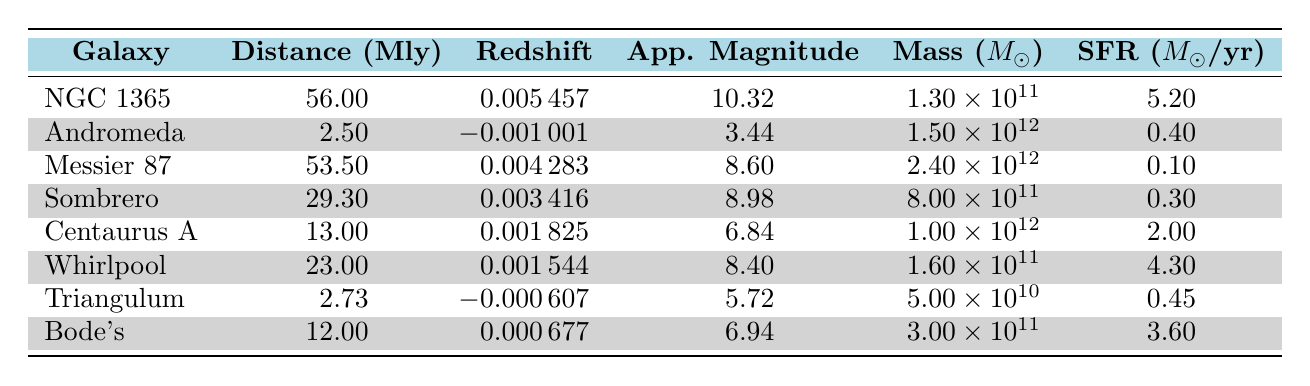What is the distance to the Andromeda Galaxy? The table shows the distance for each galaxy listed. For the Andromeda Galaxy, the distance is specifically mentioned as 2.5 million light-years.
Answer: 2.5 million light-years Which galaxy has the highest apparent magnitude? The apparent magnitude values for all galaxies are listed in the table. An apparent magnitude of 10.32 for NGC 1365 is the highest when compared to all other values (3.44, 8.6, 8.98, 6.84, 8.4, 5.72, 6.94).
Answer: NGC 1365 What is the total mass of all the galaxies listed? To find the total mass, add the mass values of all galaxies: 1.3e11 + 1.5e12 + 2.4e12 + 8e11 + 1e12 + 1.6e11 + 5e10 + 3e11 = 4.505e12 solar masses.
Answer: 4.505e12 solar masses Is the star formation rate of the Messier 87 galaxy greater than that of the Sombrero Galaxy? The star formation rates listed are 0.1 for Messier 87 and 0.3 for Sombrero. Since 0.1 is not greater than 0.3, the statement is false.
Answer: No What is the average star formation rate of the galaxies listed? The star formation rates are: 5.2, 0.4, 0.1, 0.3, 2, 4.3, 0.45, and 3.6. The sum of these is 16.35, and dividing by the number of galaxies (8) gives an average of 16.35 / 8 = 2.04375.
Answer: 2.04375 Which galaxy has the lowest redshift? The redshift values are: 0.005457 (NGC 1365), -0.001001 (Andromeda), 0.004283 (Messier 87), 0.003416 (Sombrero), 0.001825 (Centaurus A), 0.001544 (Whirlpool), -0.000607 (Triangulum), and 0.000677 (Bode's). The lowest value is -0.001001 for Andromeda.
Answer: Andromeda Galaxy Which galaxy has a mass greater than 1 trillion solar masses and an apparent magnitude lower than 7? Only Centaurus A with a mass of 1e12 and an apparent magnitude of 6.84 meets this condition, as others either exceed mass or have higher apparent magnitudes.
Answer: Centaurus A What percentage of star formation rates are above 1? The star formation rates above 1 are 5.2, 2, and 4.3. This is 3 out of 8 total values. Therefore, the percentage is (3/8) * 100 = 37.5%.
Answer: 37.5% 